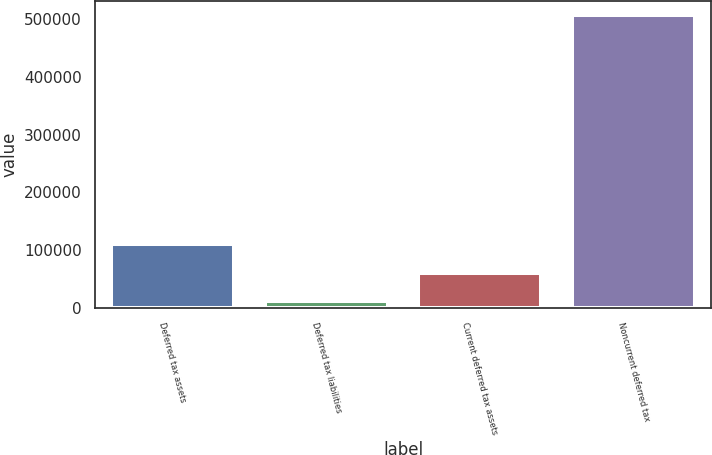Convert chart to OTSL. <chart><loc_0><loc_0><loc_500><loc_500><bar_chart><fcel>Deferred tax assets<fcel>Deferred tax liabilities<fcel>Current deferred tax assets<fcel>Noncurrent deferred tax<nl><fcel>110390<fcel>11148<fcel>60769<fcel>507358<nl></chart> 